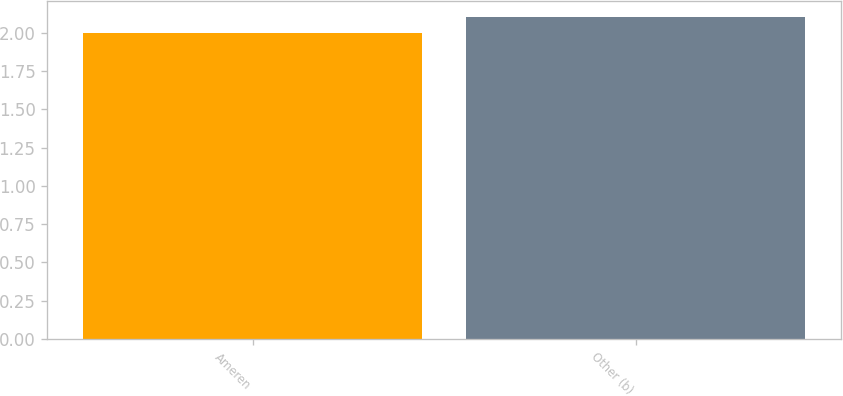<chart> <loc_0><loc_0><loc_500><loc_500><bar_chart><fcel>Ameren<fcel>Other (b)<nl><fcel>2<fcel>2.1<nl></chart> 